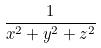<formula> <loc_0><loc_0><loc_500><loc_500>\frac { 1 } { x ^ { 2 } + y ^ { 2 } + z ^ { 2 } }</formula> 